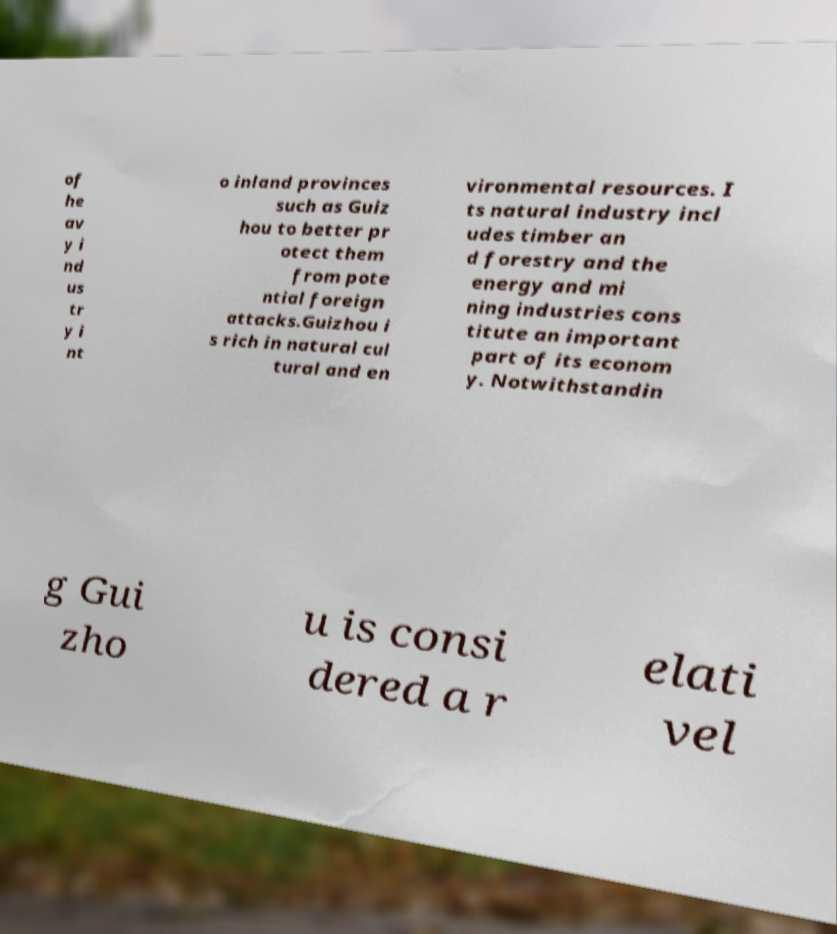Can you accurately transcribe the text from the provided image for me? of he av y i nd us tr y i nt o inland provinces such as Guiz hou to better pr otect them from pote ntial foreign attacks.Guizhou i s rich in natural cul tural and en vironmental resources. I ts natural industry incl udes timber an d forestry and the energy and mi ning industries cons titute an important part of its econom y. Notwithstandin g Gui zho u is consi dered a r elati vel 